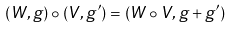<formula> <loc_0><loc_0><loc_500><loc_500>( W , g ) \circ ( V , g ^ { \prime } ) = ( W \circ V , g + g ^ { \prime } )</formula> 